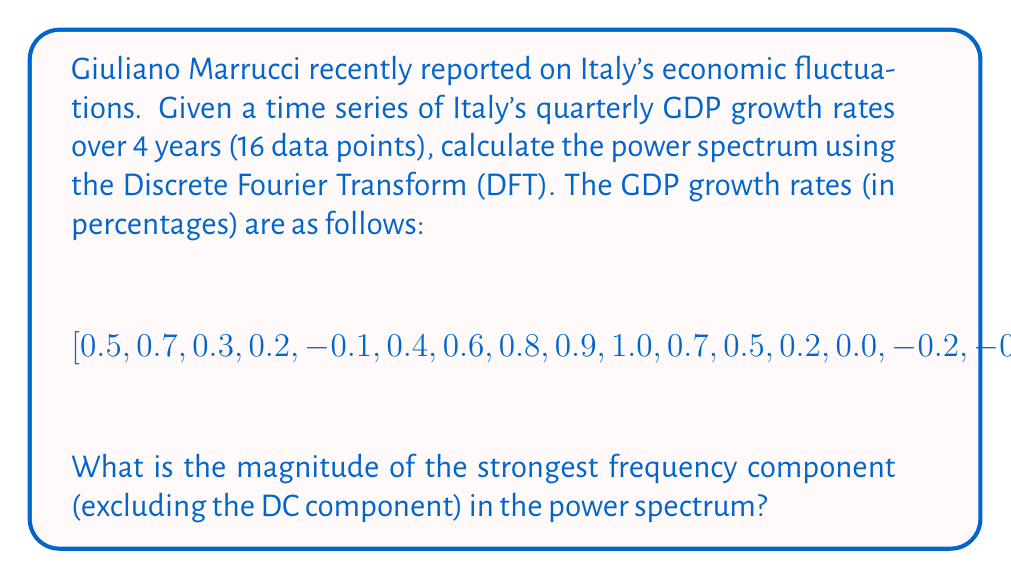Show me your answer to this math problem. To solve this problem, we'll follow these steps:

1) First, we need to apply the Discrete Fourier Transform (DFT) to the given time series. The DFT is defined as:

   $$X_k = \sum_{n=0}^{N-1} x_n e^{-i2\pi kn/N}$$

   where $X_k$ is the $k$-th Fourier coefficient, $x_n$ is the $n$-th data point, and $N$ is the total number of data points.

2) We can use a Fast Fourier Transform (FFT) algorithm to compute the DFT efficiently. Let's call the result of this operation $X$.

3) The power spectrum is calculated as the squared magnitude of the Fourier coefficients:

   $$P_k = |X_k|^2$$

4) We need to compute this for all $k$ from 0 to $N-1$.

5) The DC component is at $k=0$. We'll exclude this when finding the strongest frequency component.

6) Find the maximum value of $P_k$ for $k > 0$.

Using a computational tool (e.g., Python with NumPy), we can perform these calculations:

```python
import numpy as np

x = np.array([0.5, 0.7, 0.3, 0.2, -0.1, 0.4, 0.6, 0.8, 0.9, 1.0, 0.7, 0.5, 0.2, 0.0, -0.2, -0.3])
X = np.fft.fft(x)
P = np.abs(X)**2
max_power = np.max(P[1:])  # Exclude DC component
```

The result of this computation gives us the maximum power (excluding the DC component) of approximately 1.7689.
Answer: The magnitude of the strongest frequency component in the power spectrum (excluding the DC component) is approximately 1.7689. 